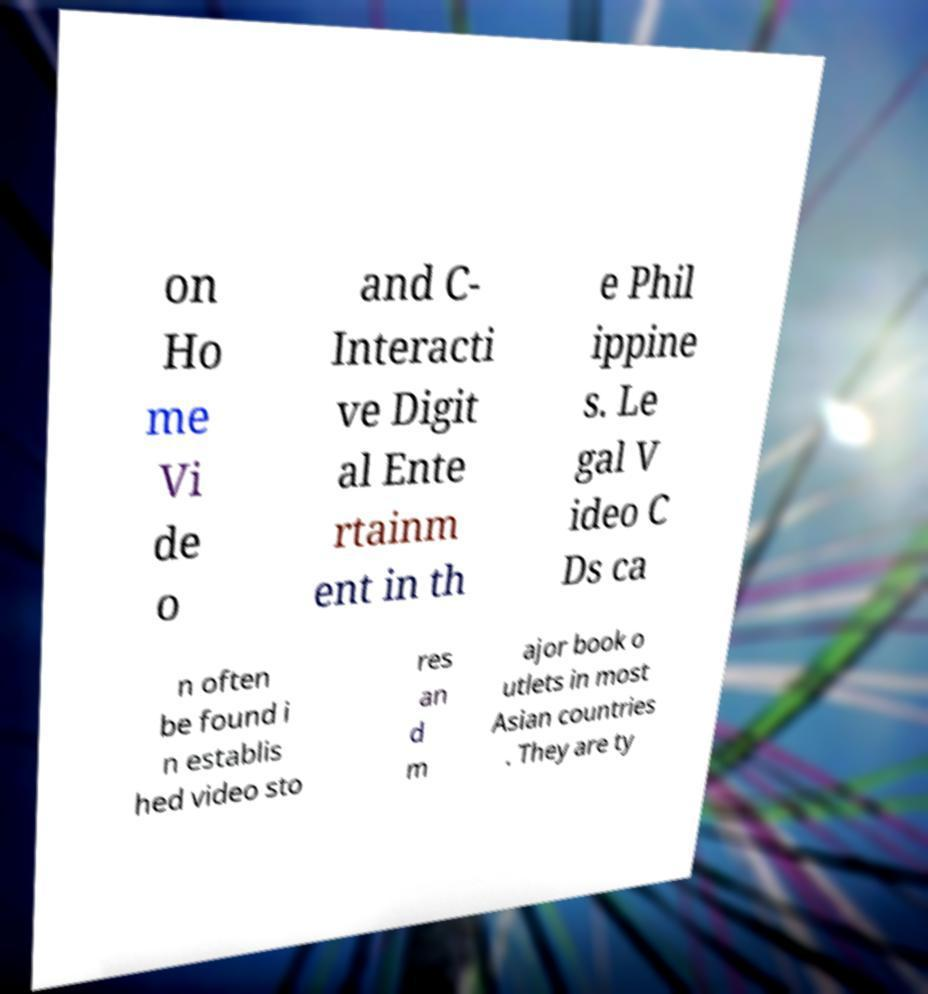Can you accurately transcribe the text from the provided image for me? on Ho me Vi de o and C- Interacti ve Digit al Ente rtainm ent in th e Phil ippine s. Le gal V ideo C Ds ca n often be found i n establis hed video sto res an d m ajor book o utlets in most Asian countries . They are ty 